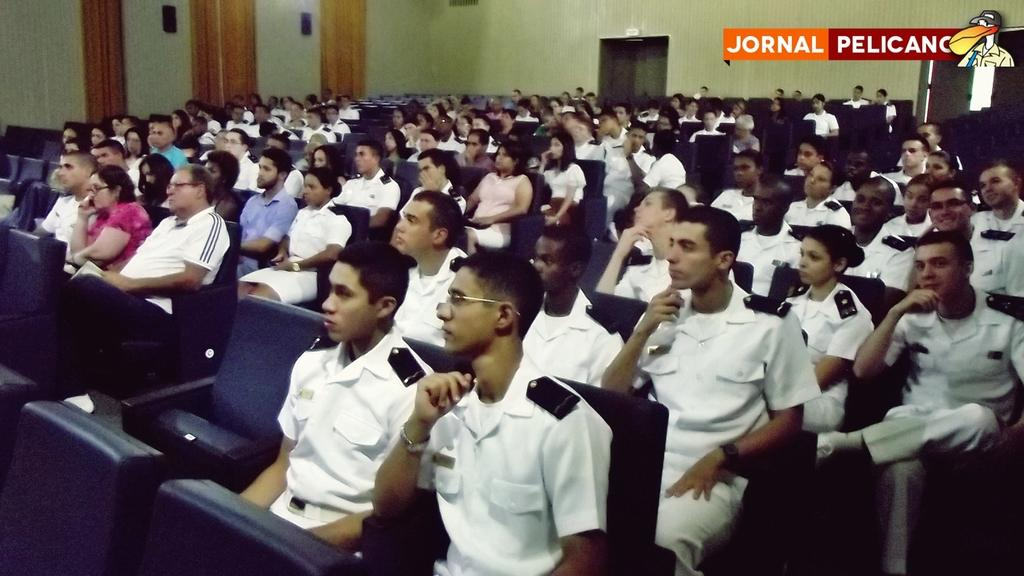What are the people in the image doing? The people in the image are sitting. What can be seen in the background of the image? There is a wall and a door visible in the background. What type of furniture is present in the image? There are chairs in the image. What type of field can be seen in the image? There is no field present in the image. What does the image smell like? The image does not have a smell, as it is a visual representation. 